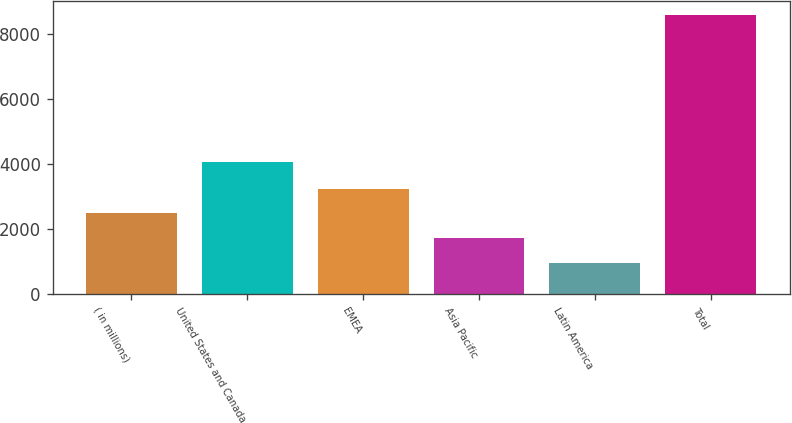Convert chart. <chart><loc_0><loc_0><loc_500><loc_500><bar_chart><fcel>( in millions)<fcel>United States and Canada<fcel>EMEA<fcel>Asia Pacific<fcel>Latin America<fcel>Total<nl><fcel>2473.6<fcel>4055<fcel>3236.9<fcel>1710.3<fcel>947<fcel>8580<nl></chart> 